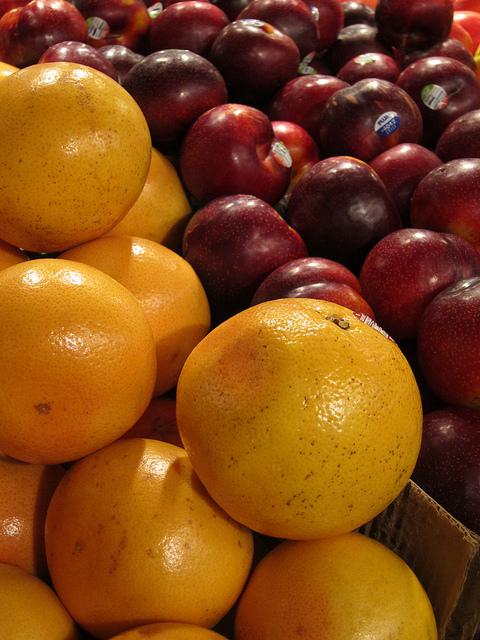Can one fruit be sliced and juiced?
Be succinct. Yes. Could you make a pie out of the fruits on the left?
Keep it brief. No. How many cherries are there?
Keep it brief. 0. 